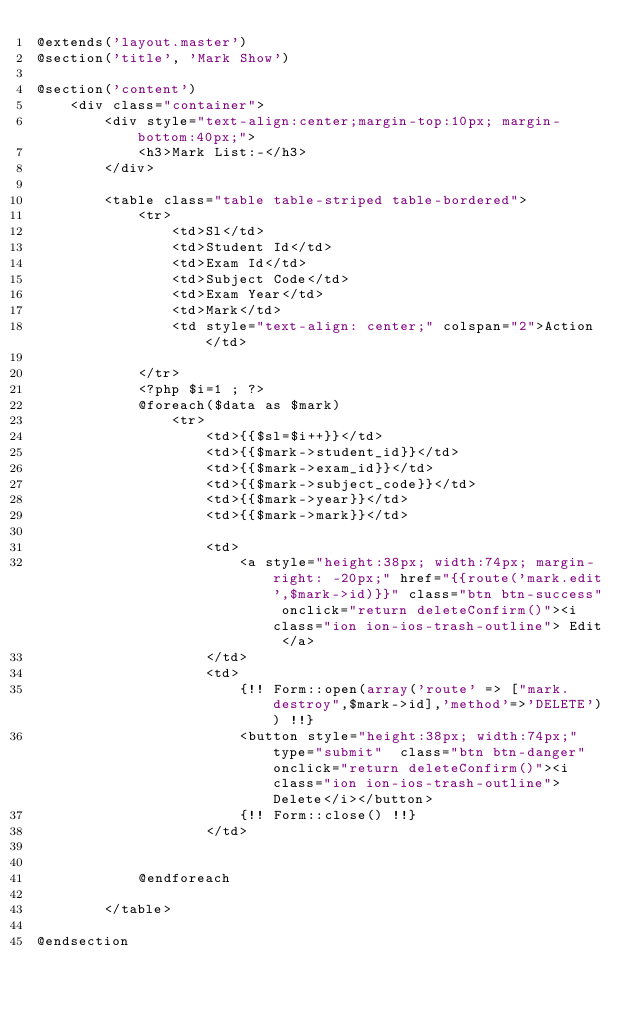Convert code to text. <code><loc_0><loc_0><loc_500><loc_500><_PHP_>@extends('layout.master')
@section('title', 'Mark Show')

@section('content')
    <div class="container">
        <div style="text-align:center;margin-top:10px; margin-bottom:40px;">
            <h3>Mark List:-</h3>
        </div>

        <table class="table table-striped table-bordered">
            <tr>
                <td>Sl</td>
                <td>Student Id</td>
                <td>Exam Id</td>
                <td>Subject Code</td>
                <td>Exam Year</td>
                <td>Mark</td>
                <td style="text-align: center;" colspan="2">Action</td>

            </tr>
            <?php $i=1 ; ?>
            @foreach($data as $mark)
                <tr>
                    <td>{{$sl=$i++}}</td>
                    <td>{{$mark->student_id}}</td>
                    <td>{{$mark->exam_id}}</td>
                    <td>{{$mark->subject_code}}</td>
                    <td>{{$mark->year}}</td>
                    <td>{{$mark->mark}}</td>

                    <td>
                        <a style="height:38px; width:74px; margin-right: -20px;" href="{{route('mark.edit',$mark->id)}}" class="btn btn-success" onclick="return deleteConfirm()"><i class="ion ion-ios-trash-outline"> Edit </a>
                    </td>
                    <td>
                        {!! Form::open(array('route' => ["mark.destroy",$mark->id],'method'=>'DELETE')) !!}
                        <button style="height:38px; width:74px;" type="submit"  class="btn btn-danger" onclick="return deleteConfirm()"><i class="ion ion-ios-trash-outline">Delete</i></button>
                        {!! Form::close() !!}
                    </td>


            @endforeach

        </table>

@endsection</code> 